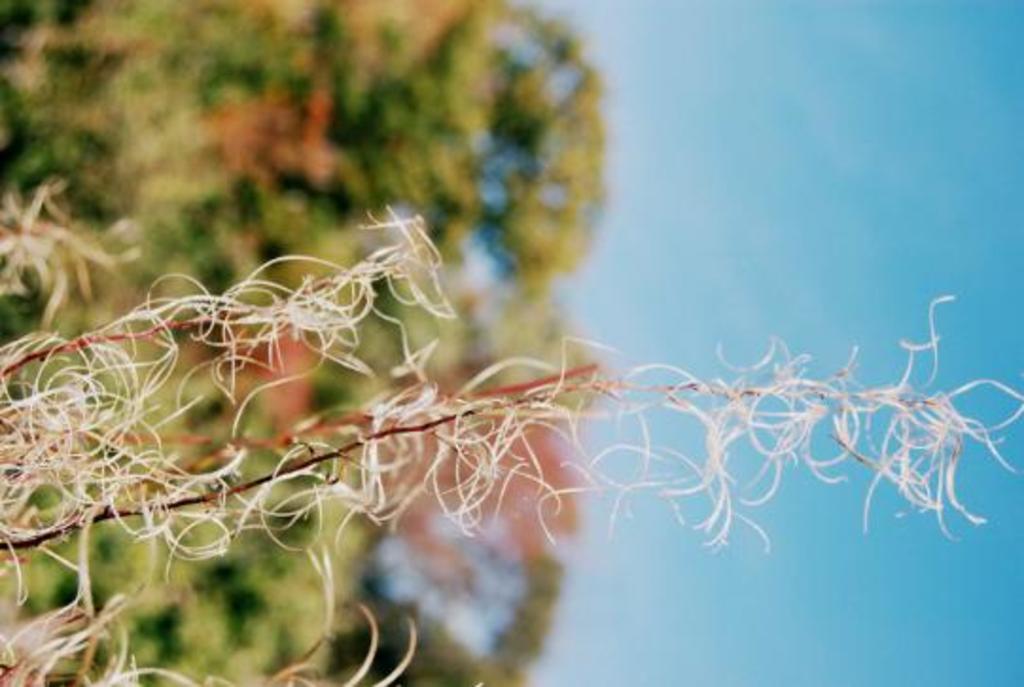In one or two sentences, can you explain what this image depicts? Here we can see a plant. There is a blur background with greenery and this is sky. 